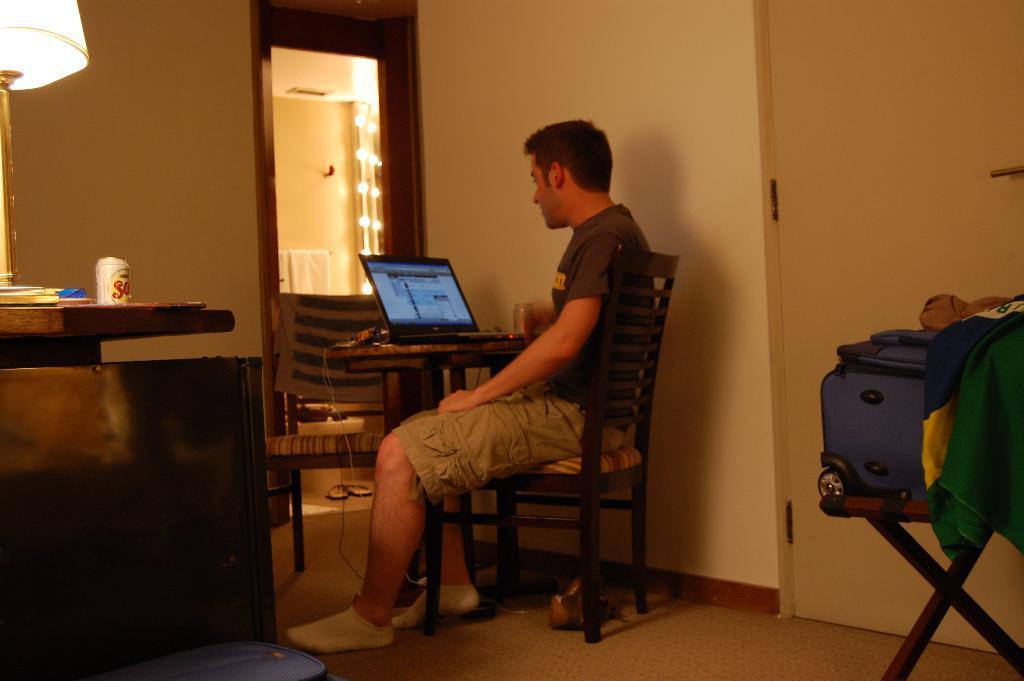Please provide a concise description of this image. In this picture a man is sitting an a chair wearing a t-shirt he is wearing socks and looking at a laptop, and beside him there is a wall and door and on the chair, there is the travelling bag, here is the floor and lamp on the table. 